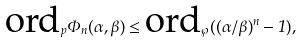<formula> <loc_0><loc_0><loc_500><loc_500>\text {ord} _ { p } \Phi _ { n } ( \alpha , \beta ) \leq \text {ord} _ { \wp } ( ( \alpha / \beta ) ^ { n } - 1 ) ,</formula> 